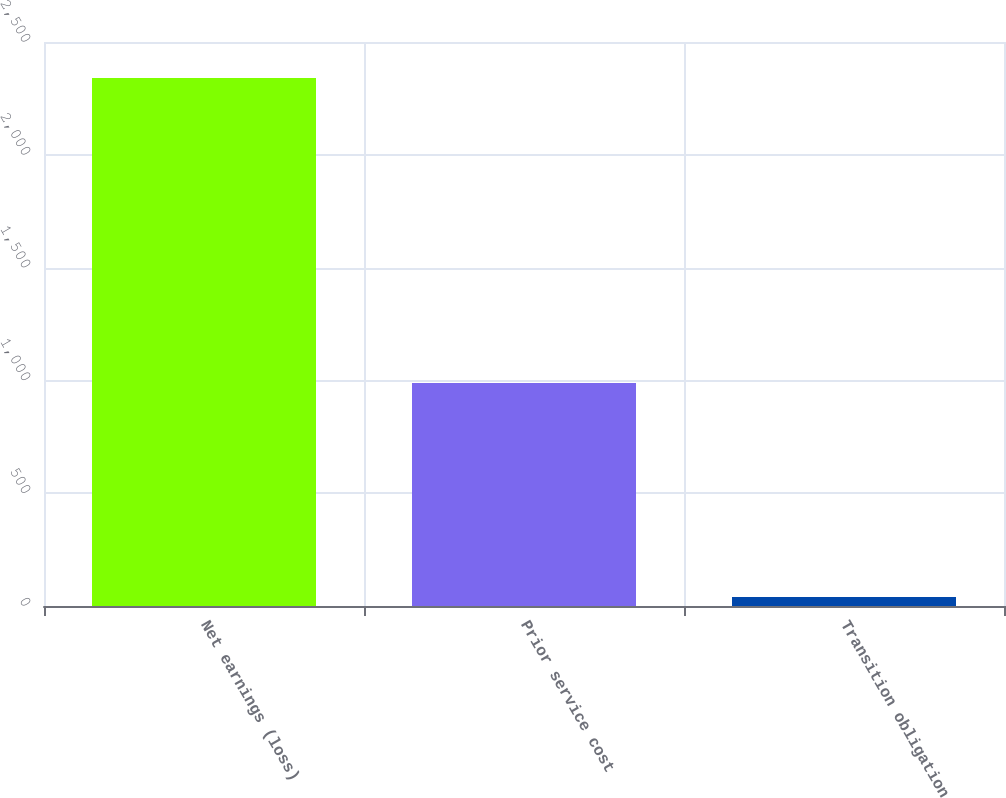Convert chart. <chart><loc_0><loc_0><loc_500><loc_500><bar_chart><fcel>Net earnings (loss)<fcel>Prior service cost<fcel>Transition obligation<nl><fcel>2340<fcel>989<fcel>40<nl></chart> 